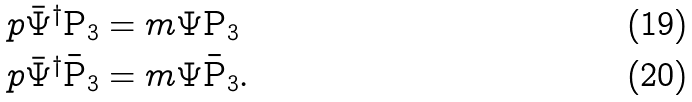<formula> <loc_0><loc_0><loc_500><loc_500>p \bar { \Psi } ^ { \dag } \text {P} _ { 3 } & = m \Psi \text {P} _ { 3 } \\ p \bar { \Psi } ^ { \dag } \text {\={P}} _ { 3 } & = m \Psi \text {\={P}} _ { 3 } .</formula> 